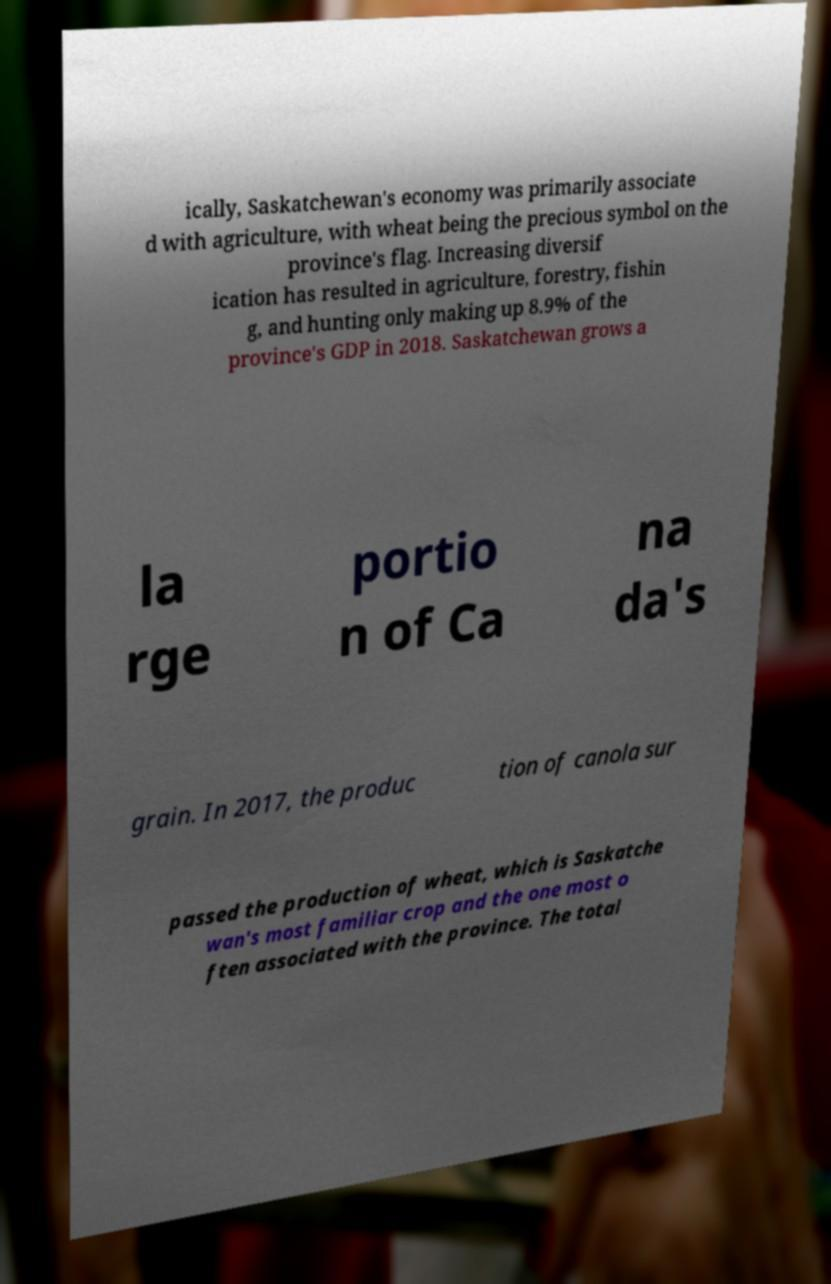I need the written content from this picture converted into text. Can you do that? ically, Saskatchewan's economy was primarily associate d with agriculture, with wheat being the precious symbol on the province's flag. Increasing diversif ication has resulted in agriculture, forestry, fishin g, and hunting only making up 8.9% of the province's GDP in 2018. Saskatchewan grows a la rge portio n of Ca na da's grain. In 2017, the produc tion of canola sur passed the production of wheat, which is Saskatche wan's most familiar crop and the one most o ften associated with the province. The total 